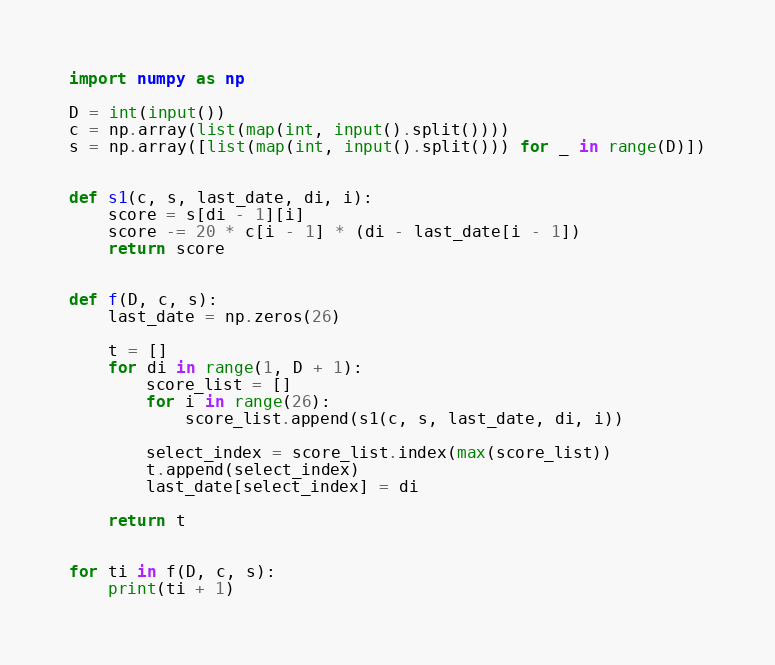Convert code to text. <code><loc_0><loc_0><loc_500><loc_500><_Python_>import numpy as np

D = int(input())
c = np.array(list(map(int, input().split())))
s = np.array([list(map(int, input().split())) for _ in range(D)])


def s1(c, s, last_date, di, i):
    score = s[di - 1][i]
    score -= 20 * c[i - 1] * (di - last_date[i - 1])
    return score


def f(D, c, s):
    last_date = np.zeros(26)

    t = []
    for di in range(1, D + 1):
        score_list = []
        for i in range(26):
            score_list.append(s1(c, s, last_date, di, i))

        select_index = score_list.index(max(score_list))
        t.append(select_index)
        last_date[select_index] = di

    return t


for ti in f(D, c, s):
    print(ti + 1)</code> 